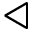<formula> <loc_0><loc_0><loc_500><loc_500>\triangleleft</formula> 